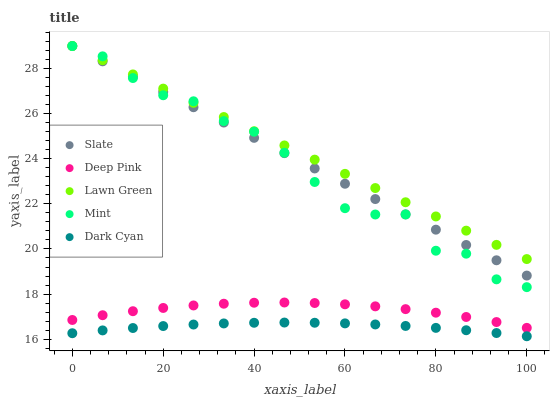Does Dark Cyan have the minimum area under the curve?
Answer yes or no. Yes. Does Lawn Green have the maximum area under the curve?
Answer yes or no. Yes. Does Slate have the minimum area under the curve?
Answer yes or no. No. Does Slate have the maximum area under the curve?
Answer yes or no. No. Is Slate the smoothest?
Answer yes or no. Yes. Is Mint the roughest?
Answer yes or no. Yes. Is Lawn Green the smoothest?
Answer yes or no. No. Is Lawn Green the roughest?
Answer yes or no. No. Does Dark Cyan have the lowest value?
Answer yes or no. Yes. Does Slate have the lowest value?
Answer yes or no. No. Does Mint have the highest value?
Answer yes or no. Yes. Does Deep Pink have the highest value?
Answer yes or no. No. Is Dark Cyan less than Mint?
Answer yes or no. Yes. Is Mint greater than Dark Cyan?
Answer yes or no. Yes. Does Slate intersect Lawn Green?
Answer yes or no. Yes. Is Slate less than Lawn Green?
Answer yes or no. No. Is Slate greater than Lawn Green?
Answer yes or no. No. Does Dark Cyan intersect Mint?
Answer yes or no. No. 